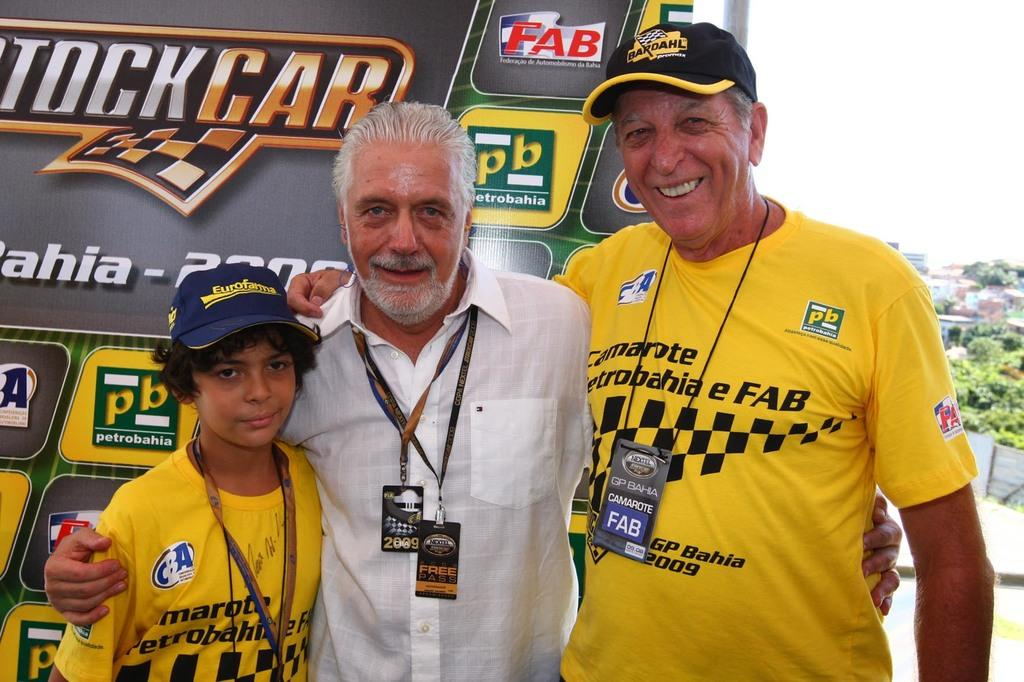Provide a one-sentence caption for the provided image. Man wearing a yellow shirt that says "FAB" posing for a photo. 